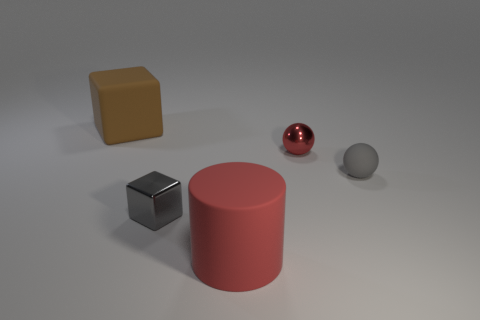Add 4 small gray metallic things. How many objects exist? 9 Subtract all blocks. How many objects are left? 3 Add 4 large gray matte spheres. How many large gray matte spheres exist? 4 Subtract 0 blue cylinders. How many objects are left? 5 Subtract all gray blocks. Subtract all big purple cylinders. How many objects are left? 4 Add 2 small things. How many small things are left? 5 